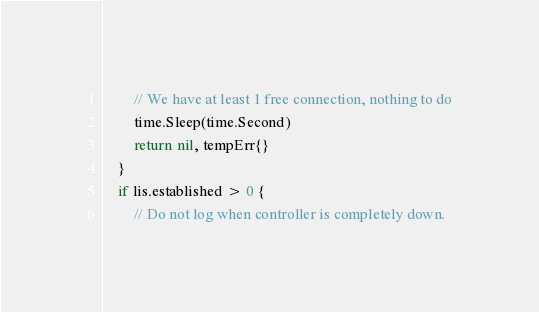<code> <loc_0><loc_0><loc_500><loc_500><_Go_>		// We have at least 1 free connection, nothing to do
		time.Sleep(time.Second)
		return nil, tempErr{}
	}
	if lis.established > 0 {
		// Do not log when controller is completely down.</code> 